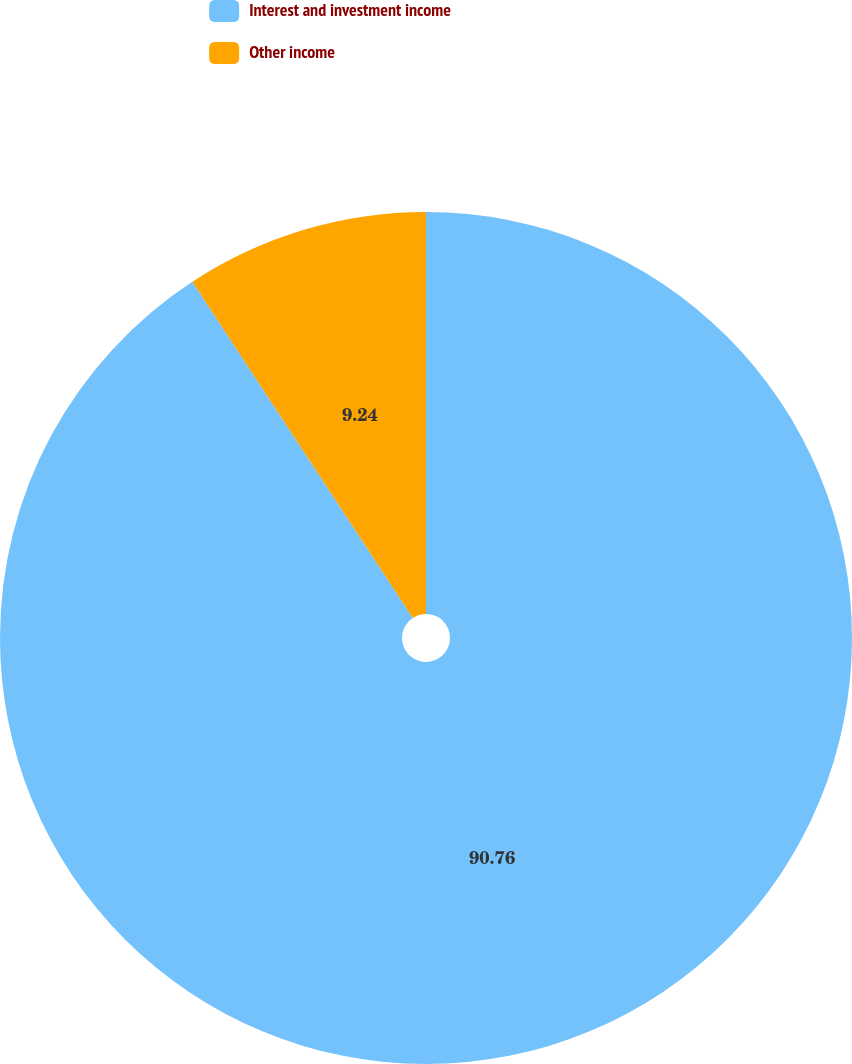Convert chart to OTSL. <chart><loc_0><loc_0><loc_500><loc_500><pie_chart><fcel>Interest and investment income<fcel>Other income<nl><fcel>90.76%<fcel>9.24%<nl></chart> 